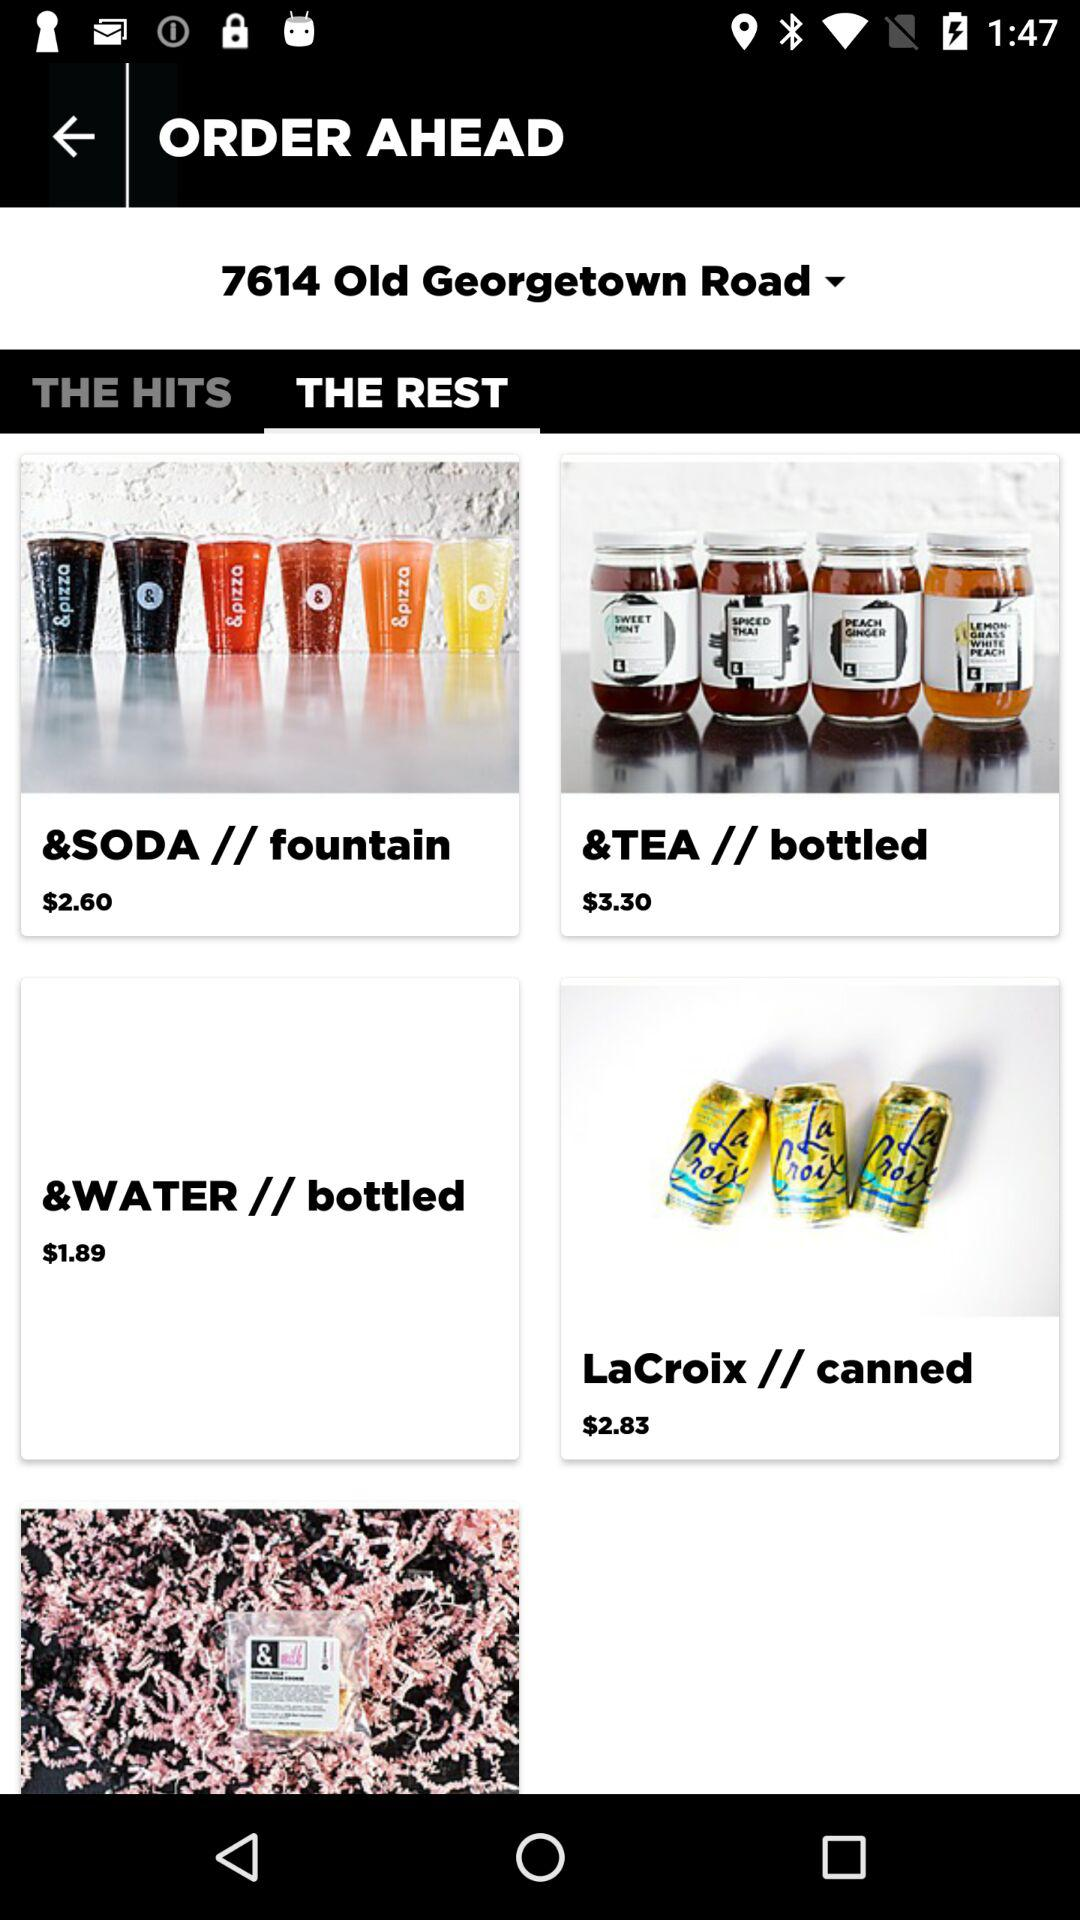What is the price for the "&SODA // fountain"? The price is $2.60. 